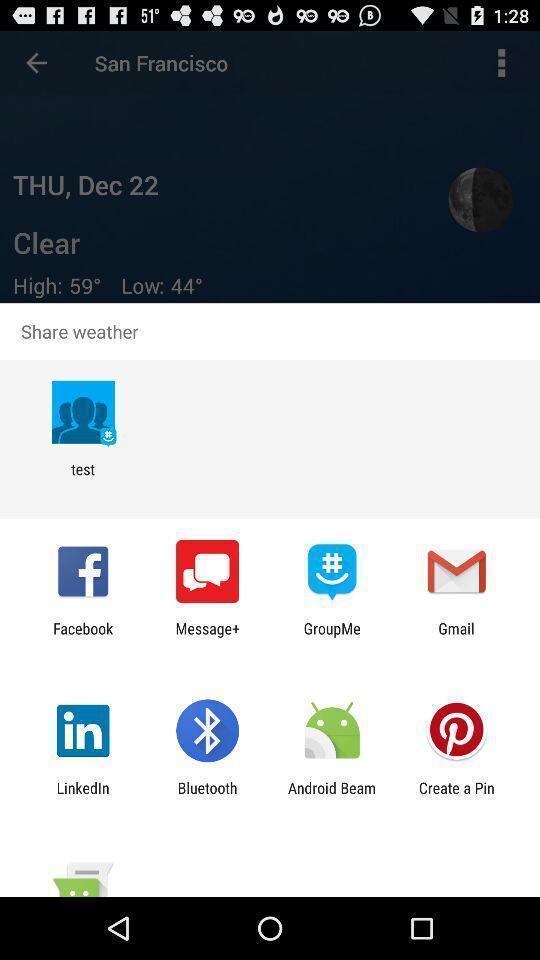Describe the visual elements of this screenshot. Widget showing lot of data sharing apps. 